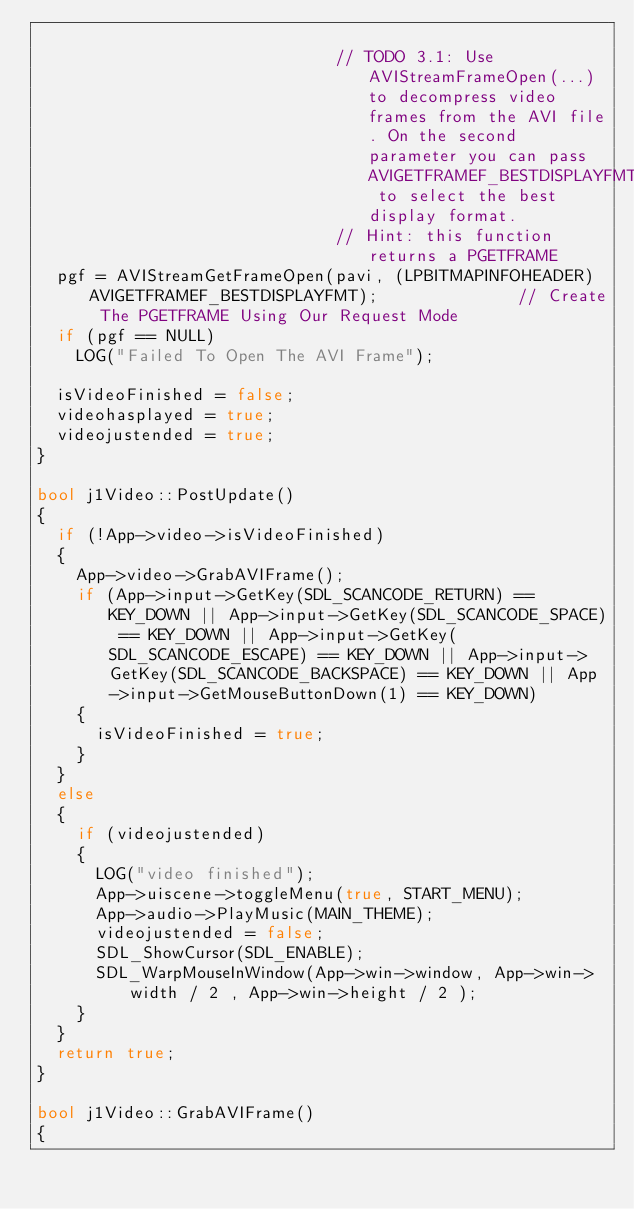Convert code to text. <code><loc_0><loc_0><loc_500><loc_500><_C++_>
															// TODO 3.1: Use AVIStreamFrameOpen(...) to decompress video frames from the AVI file. On the second parameter you can pass AVIGETFRAMEF_BESTDISPLAYFMT to select the best display format.
															// Hint: this function returns a PGETFRAME
	pgf = AVIStreamGetFrameOpen(pavi, (LPBITMAPINFOHEADER)AVIGETFRAMEF_BESTDISPLAYFMT);              // Create The PGETFRAME Using Our Request Mode
	if (pgf == NULL)
		LOG("Failed To Open The AVI Frame");

	isVideoFinished = false;
	videohasplayed = true;
	videojustended = true;
}

bool j1Video::PostUpdate()
{
	if (!App->video->isVideoFinished)
	{
		App->video->GrabAVIFrame();
		if (App->input->GetKey(SDL_SCANCODE_RETURN) == KEY_DOWN || App->input->GetKey(SDL_SCANCODE_SPACE) == KEY_DOWN || App->input->GetKey(SDL_SCANCODE_ESCAPE) == KEY_DOWN || App->input->GetKey(SDL_SCANCODE_BACKSPACE) == KEY_DOWN || App->input->GetMouseButtonDown(1) == KEY_DOWN)
		{
			isVideoFinished = true;
		}
	}
	else
	{
		if (videojustended)
		{
			LOG("video finished");
			App->uiscene->toggleMenu(true, START_MENU);
			App->audio->PlayMusic(MAIN_THEME);
			videojustended = false;
			SDL_ShowCursor(SDL_ENABLE);
			SDL_WarpMouseInWindow(App->win->window, App->win->width / 2 , App->win->height / 2 );
		}
	}
	return true;
}

bool j1Video::GrabAVIFrame()
{</code> 